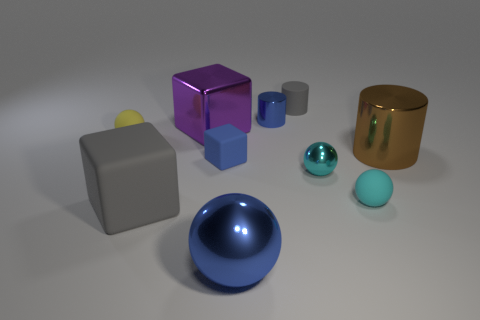What number of other shiny objects are the same shape as the yellow thing?
Offer a terse response. 2. Is the number of tiny yellow matte spheres behind the yellow thing greater than the number of large matte objects?
Your response must be concise. No. What shape is the gray object that is behind the rubber sphere to the right of the gray matte thing that is left of the purple metal cube?
Keep it short and to the point. Cylinder. There is a gray rubber object on the left side of the gray cylinder; is its shape the same as the small object that is right of the cyan shiny ball?
Provide a short and direct response. No. Is there any other thing that has the same size as the yellow matte object?
Keep it short and to the point. Yes. How many blocks are either brown metal things or tiny gray things?
Offer a terse response. 0. Does the blue sphere have the same material as the tiny cube?
Ensure brevity in your answer.  No. How many other things are the same color as the big metallic ball?
Offer a terse response. 2. What shape is the small metal object that is in front of the small blue cube?
Your response must be concise. Sphere. What number of things are brown metallic cylinders or large matte balls?
Provide a succinct answer. 1. 